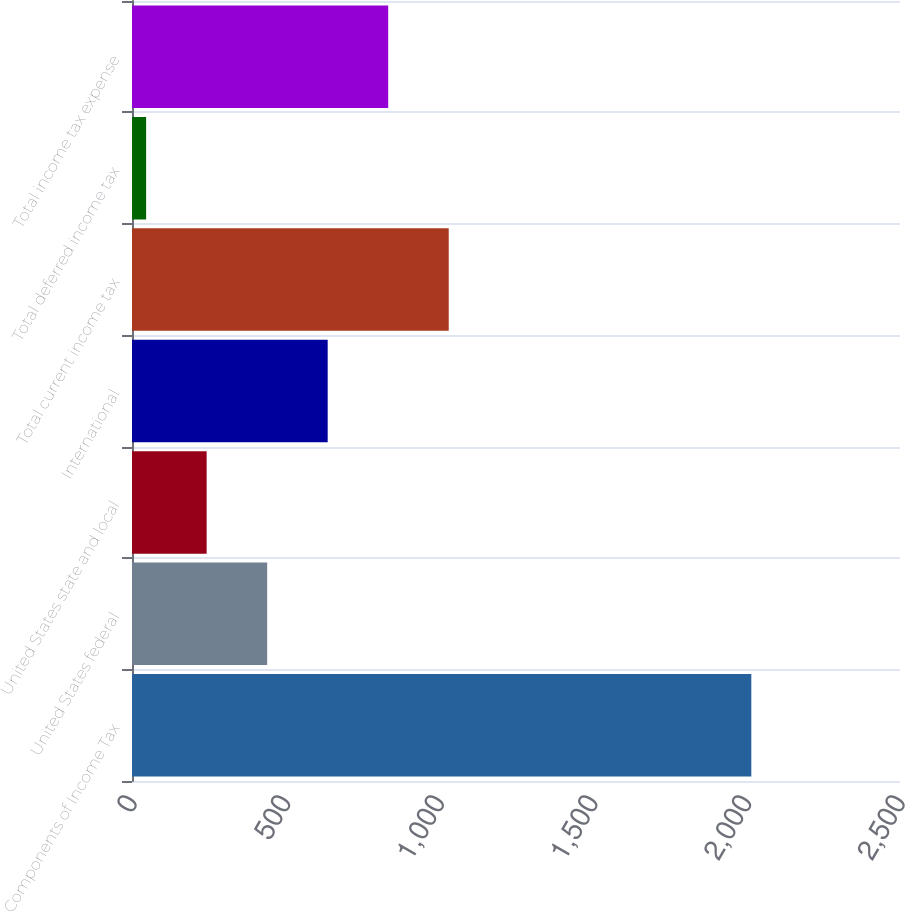<chart> <loc_0><loc_0><loc_500><loc_500><bar_chart><fcel>Components of Income Tax<fcel>United States federal<fcel>United States state and local<fcel>International<fcel>Total current income tax<fcel>Total deferred income tax<fcel>Total income tax expense<nl><fcel>2016<fcel>440<fcel>243<fcel>637<fcel>1031<fcel>46<fcel>834<nl></chart> 